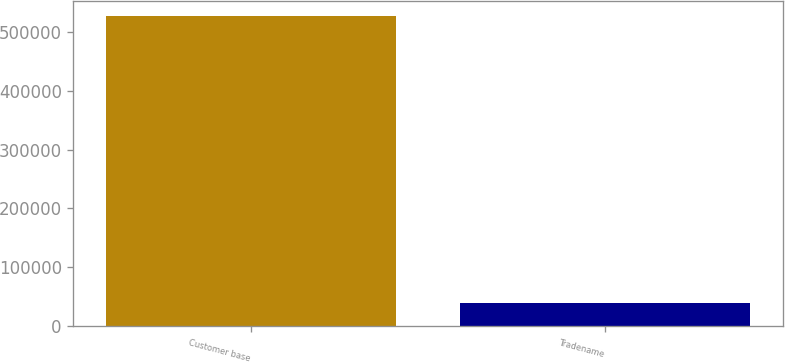Convert chart. <chart><loc_0><loc_0><loc_500><loc_500><bar_chart><fcel>Customer base<fcel>Tradename<nl><fcel>526512<fcel>38933<nl></chart> 